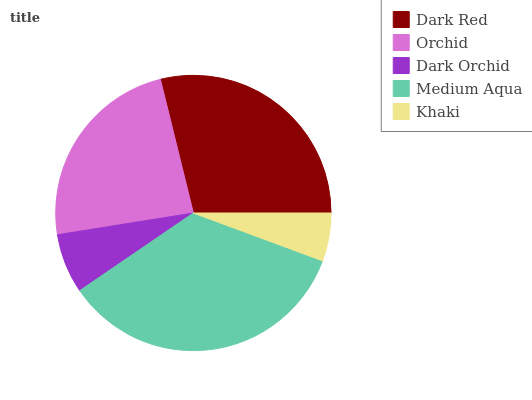Is Khaki the minimum?
Answer yes or no. Yes. Is Medium Aqua the maximum?
Answer yes or no. Yes. Is Orchid the minimum?
Answer yes or no. No. Is Orchid the maximum?
Answer yes or no. No. Is Dark Red greater than Orchid?
Answer yes or no. Yes. Is Orchid less than Dark Red?
Answer yes or no. Yes. Is Orchid greater than Dark Red?
Answer yes or no. No. Is Dark Red less than Orchid?
Answer yes or no. No. Is Orchid the high median?
Answer yes or no. Yes. Is Orchid the low median?
Answer yes or no. Yes. Is Medium Aqua the high median?
Answer yes or no. No. Is Medium Aqua the low median?
Answer yes or no. No. 